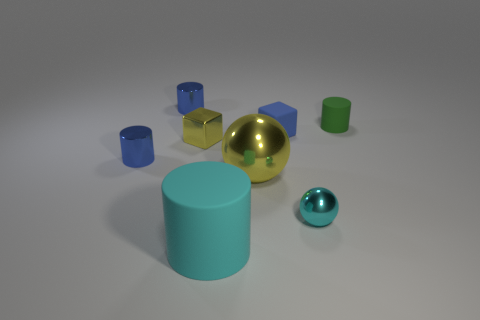Are the cyan sphere and the large object that is behind the cyan cylinder made of the same material?
Make the answer very short. Yes. There is a big thing that is the same color as the tiny metallic sphere; what is its material?
Your response must be concise. Rubber. What number of other things are the same color as the large metallic object?
Offer a terse response. 1. The green rubber cylinder is what size?
Your response must be concise. Small. Is the shape of the big yellow metallic object the same as the yellow shiny thing that is behind the big yellow object?
Make the answer very short. No. What color is the other sphere that is the same material as the small sphere?
Provide a succinct answer. Yellow. There is a cylinder to the right of the cyan cylinder; what size is it?
Provide a short and direct response. Small. Is the number of tiny yellow metallic things that are right of the large yellow metal sphere less than the number of large yellow balls?
Keep it short and to the point. Yes. Is the large matte object the same color as the small metallic cube?
Your answer should be compact. No. Is there any other thing that has the same shape as the green object?
Provide a short and direct response. Yes. 